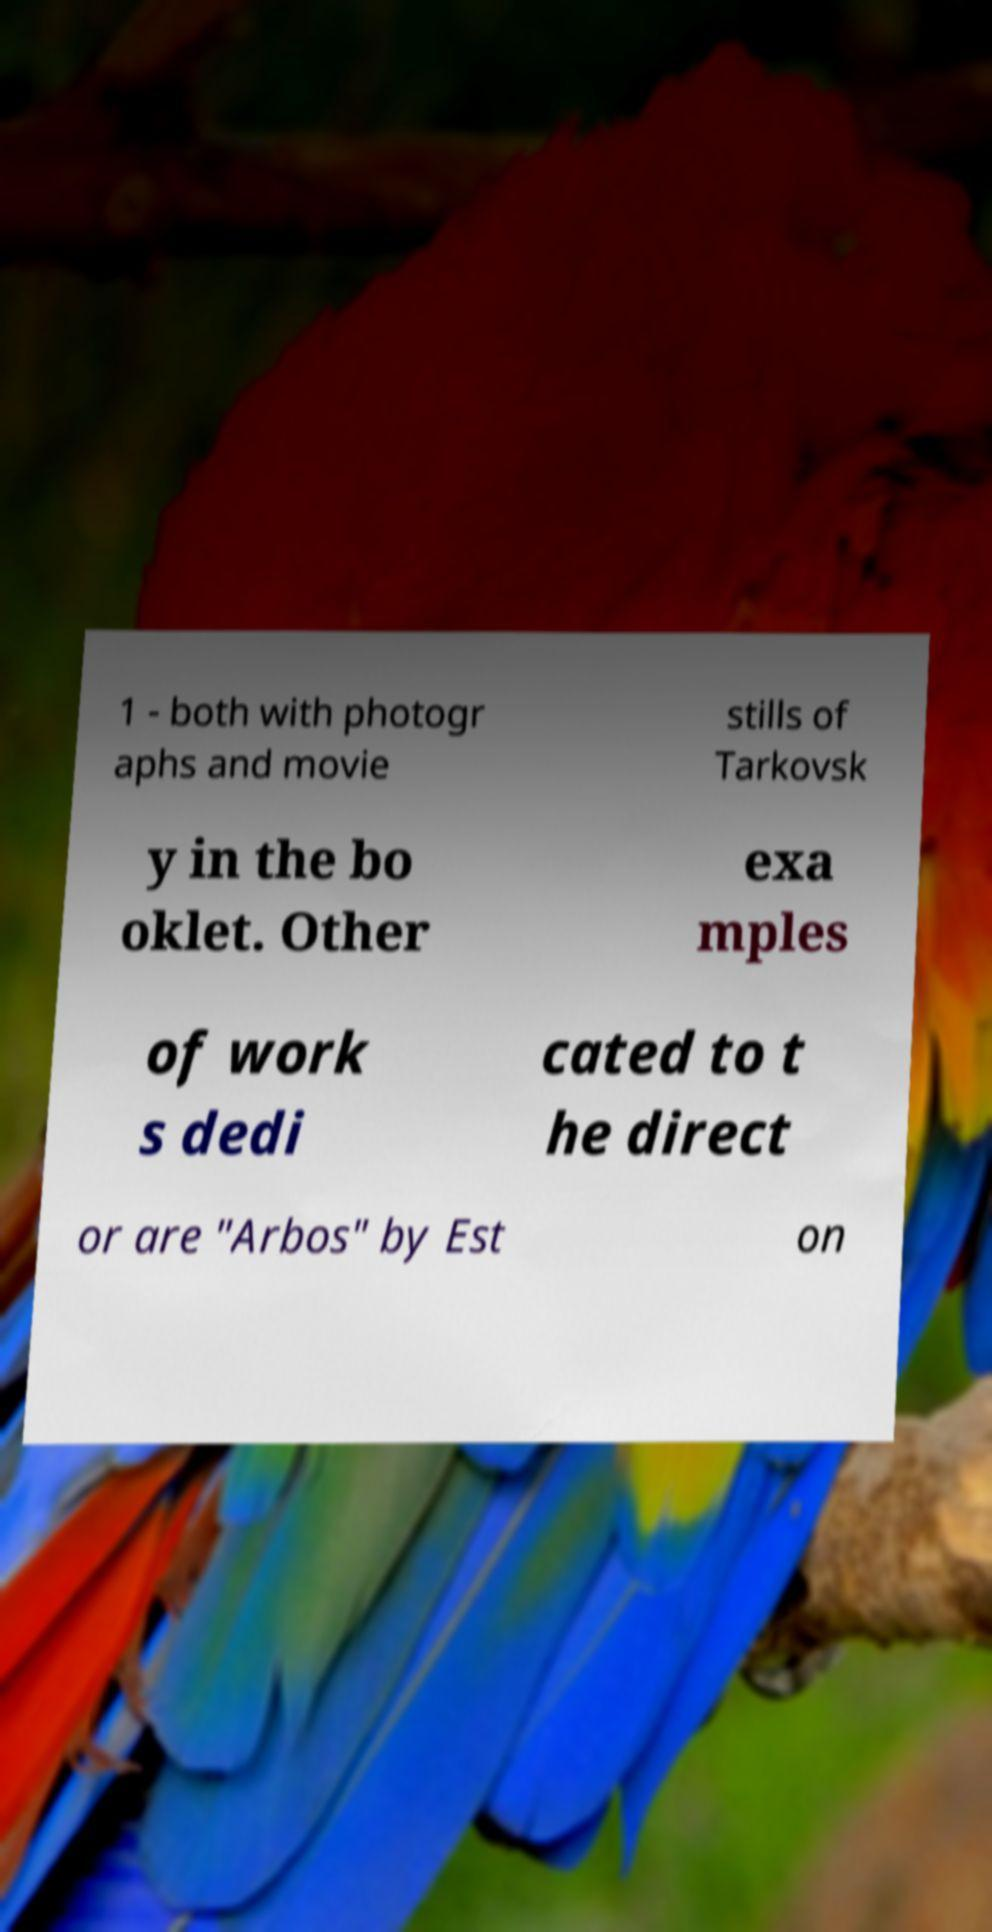There's text embedded in this image that I need extracted. Can you transcribe it verbatim? 1 - both with photogr aphs and movie stills of Tarkovsk y in the bo oklet. Other exa mples of work s dedi cated to t he direct or are "Arbos" by Est on 